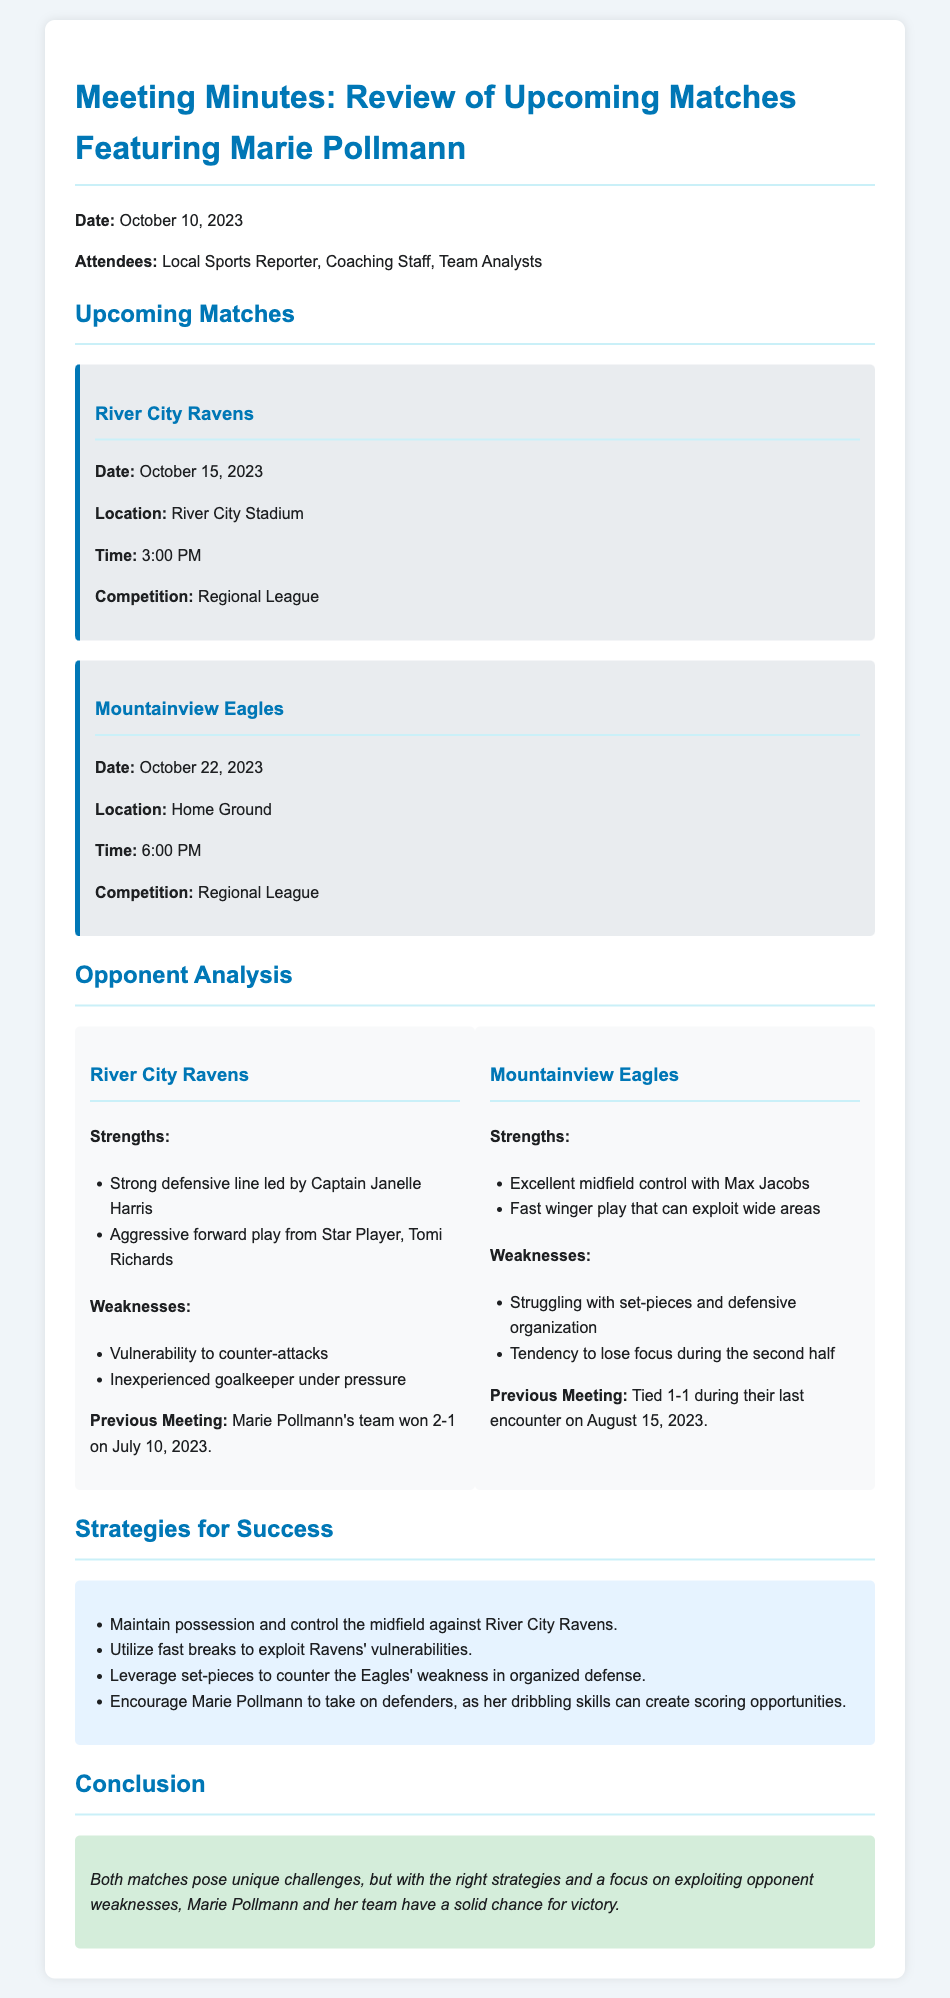What is the date of the match against River City Ravens? The date is specified in the document, which states the match against River City Ravens will take place on October 15, 2023.
Answer: October 15, 2023 Who is the captain of the River City Ravens? The document mentions that the strength of the River City Ravens includes a strong defensive line led by Captain Janelle Harris.
Answer: Janelle Harris What time is the match against Mountainview Eagles scheduled? The document lists the time for the match against Mountainview Eagles as 6:00 PM.
Answer: 6:00 PM What is a weakness of the Mountainview Eagles? The document identifies that one of the weaknesses of the Mountainview Eagles is their struggle with set-pieces and defensive organization.
Answer: Struggling with set-pieces and defensive organization What should Marie Pollmann do against the Ravens? The document suggests encouraging Marie Pollmann to take on defenders, as her dribbling skills can create scoring opportunities.
Answer: Take on defenders How did Marie Pollmann's team perform against the River City Ravens in their last meeting? The document states that Marie Pollmann's team won the previous meeting against the River City Ravens 2-1 on July 10, 2023.
Answer: Won 2-1 What is one of the strategies for success listed in the document? The document outlines several strategies, including maintaining possession and controlling the midfield against River City Ravens.
Answer: Maintain possession and control the midfield How many attendees were present during the meeting? The document lists the attendees as the Local Sports Reporter, Coaching Staff, and Team Analysts, indicating there were three groups represented.
Answer: Three groups What is the opening date of the meeting minutes? The document specifies the meeting date as October 10, 2023.
Answer: October 10, 2023 